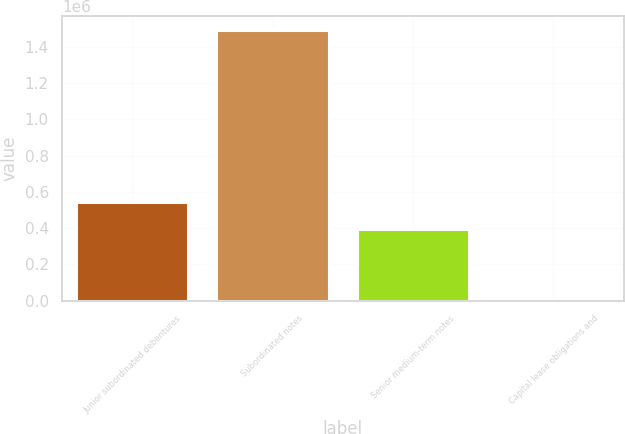Convert chart to OTSL. <chart><loc_0><loc_0><loc_500><loc_500><bar_chart><fcel>Junior subordinated debentures<fcel>Subordinated notes<fcel>Senior medium-term notes<fcel>Capital lease obligations and<nl><fcel>543912<fcel>1.49208e+06<fcel>394984<fcel>2805<nl></chart> 